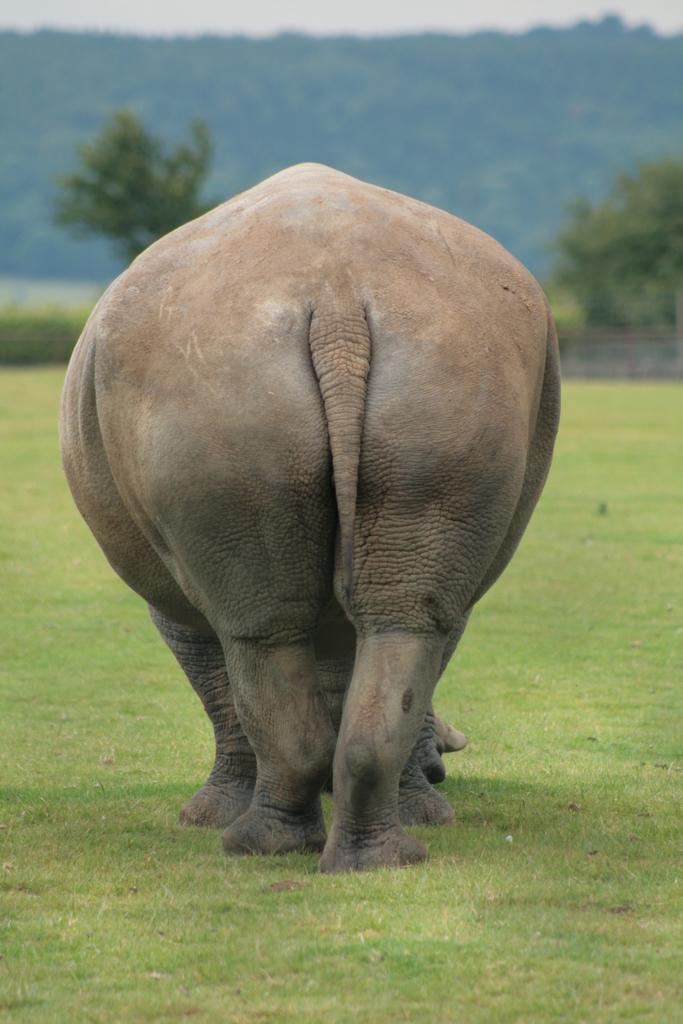Could you give a brief overview of what you see in this image? Here we can see an elephant on the ground. This is grass. In the background we can see trees and sky. 